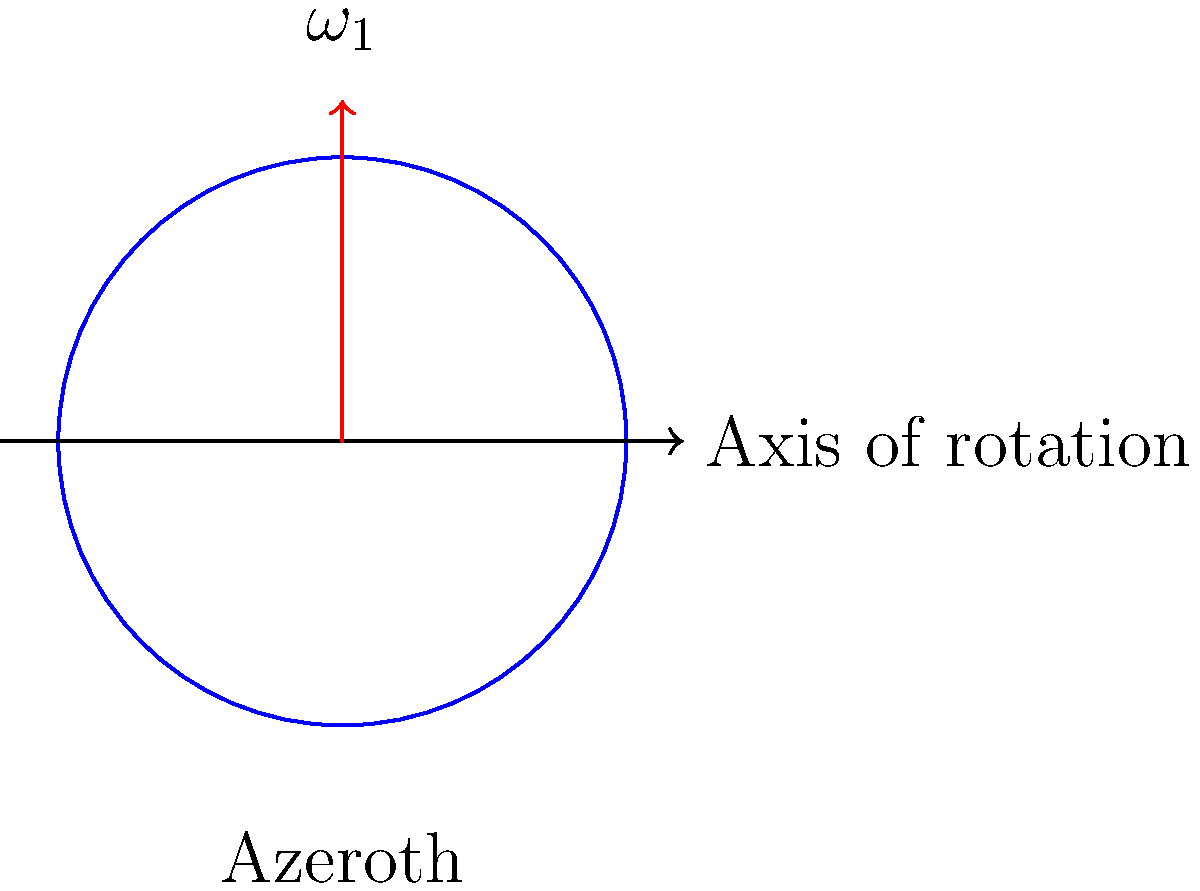In World of Warcraft, Azeroth is a planet that rotates on its axis. If an unknown cosmic force were to suddenly compress Azeroth to half its original radius while preserving its mass, how would its angular velocity change? Assume Azeroth is a perfect sphere and ignore any magical interventions. To solve this problem, we'll use the principle of conservation of angular momentum, which is analogous to how historical empires maintained power through centralization.

Step 1: Define the initial and final states
- Initial state: radius $r_1$, angular velocity $\omega_1$
- Final state: radius $r_2 = \frac{1}{2}r_1$, angular velocity $\omega_2$ (unknown)

Step 2: Express the moment of inertia
For a sphere, $I = \frac{2}{5}MR^2$, where M is the mass and R is the radius.
- Initial moment of inertia: $I_1 = \frac{2}{5}Mr_1^2$
- Final moment of inertia: $I_2 = \frac{2}{5}M(\frac{1}{2}r_1)^2 = \frac{1}{4}I_1$

Step 3: Apply conservation of angular momentum
Angular momentum $L = I\omega$ is conserved, so:
$L_1 = L_2$
$I_1\omega_1 = I_2\omega_2$

Step 4: Solve for $\omega_2$
$\frac{2}{5}Mr_1^2\omega_1 = \frac{2}{5}M(\frac{1}{2}r_1)^2\omega_2$
$r_1^2\omega_1 = \frac{1}{4}r_1^2\omega_2$
$\omega_2 = 4\omega_1$

Therefore, Azeroth's angular velocity would increase by a factor of 4, similar to how centralization of power in historical empires often led to more rapid decision-making and actions.
Answer: $\omega_2 = 4\omega_1$ 